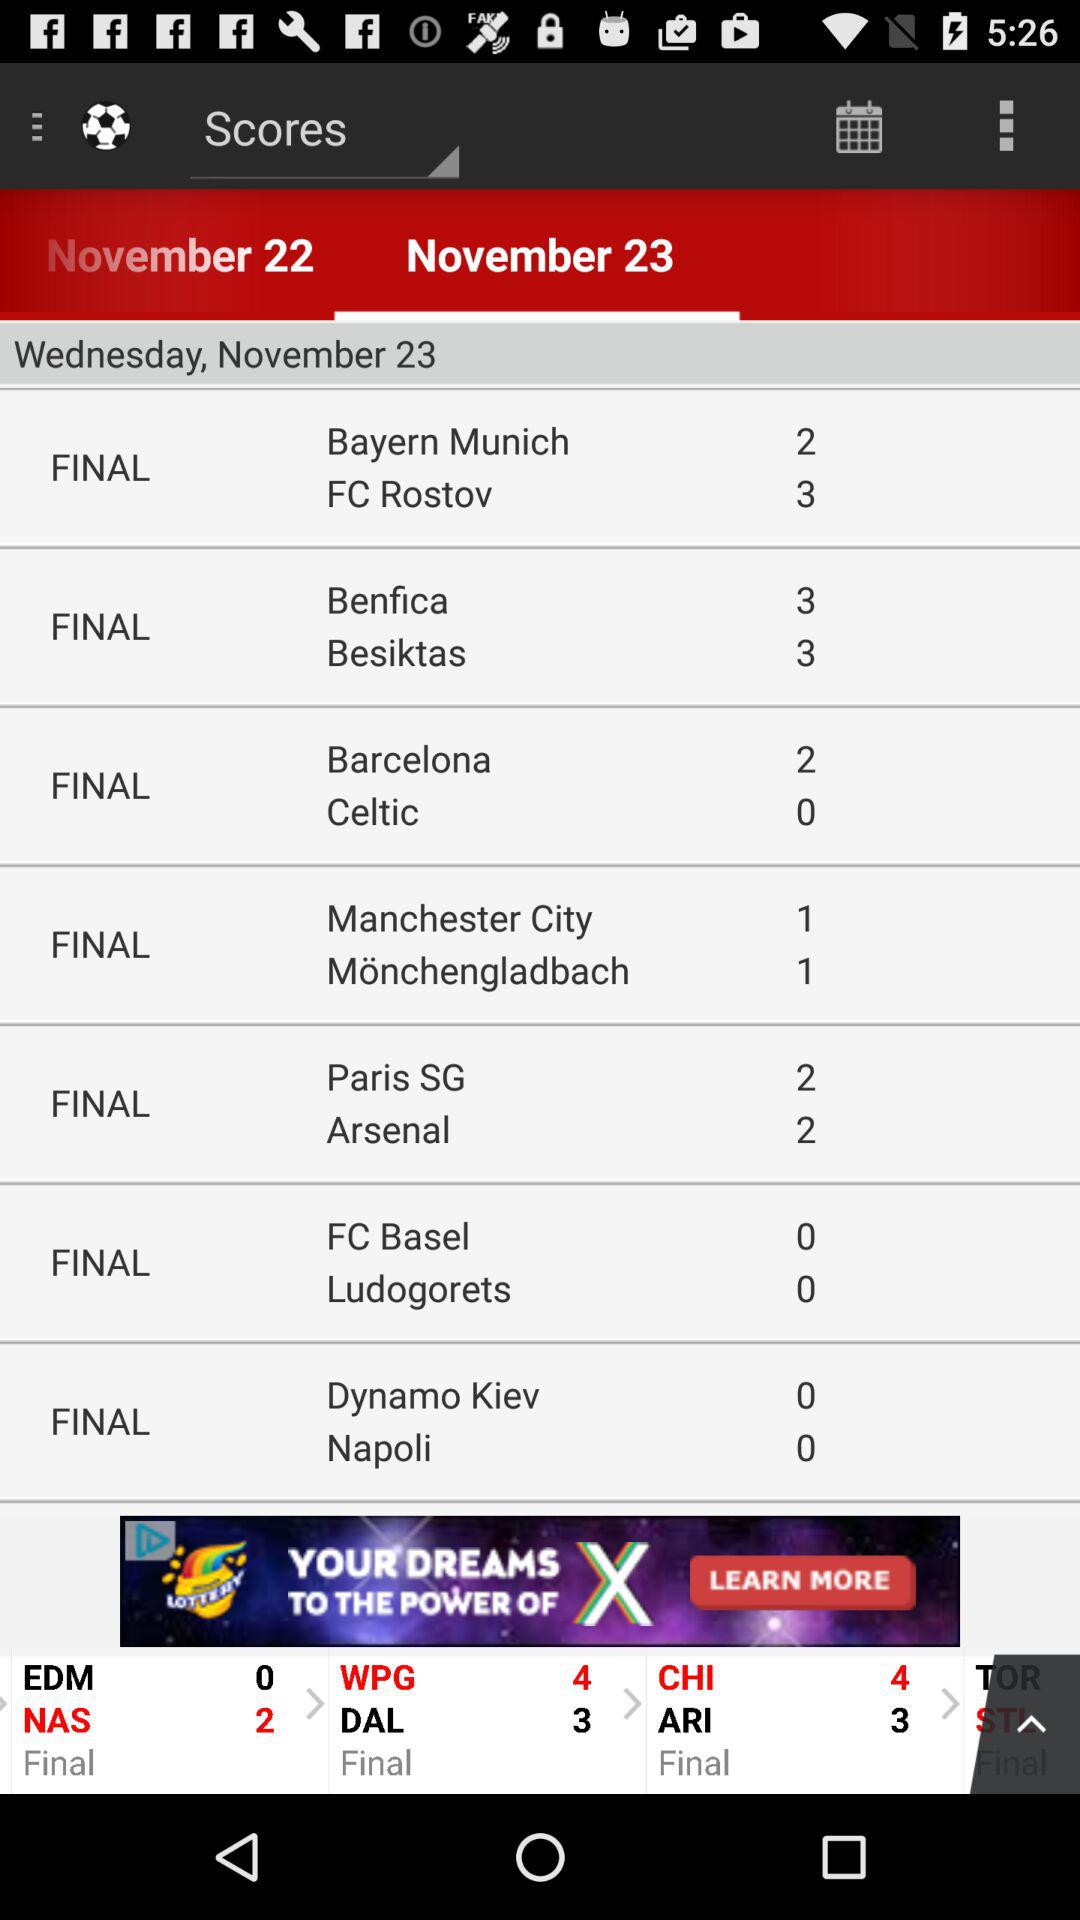What is the date of the match between Bayern Munich and FC Rostov? The date is Wednesday, November 23. 